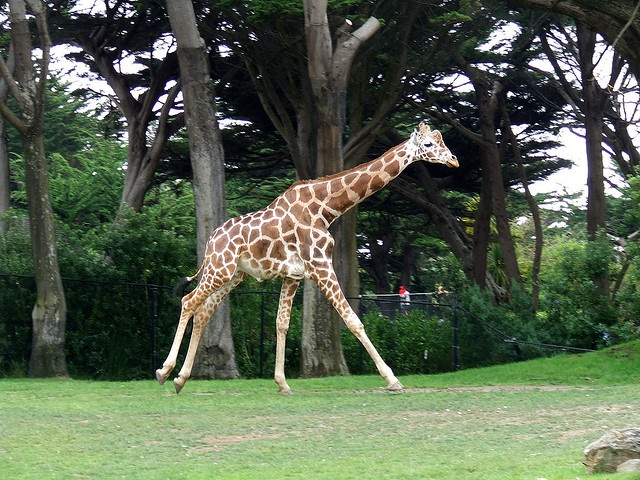Describe the objects in this image and their specific colors. I can see giraffe in black, ivory, gray, and tan tones, people in black, gray, darkgray, and lightgray tones, and people in black, gray, and darkgreen tones in this image. 